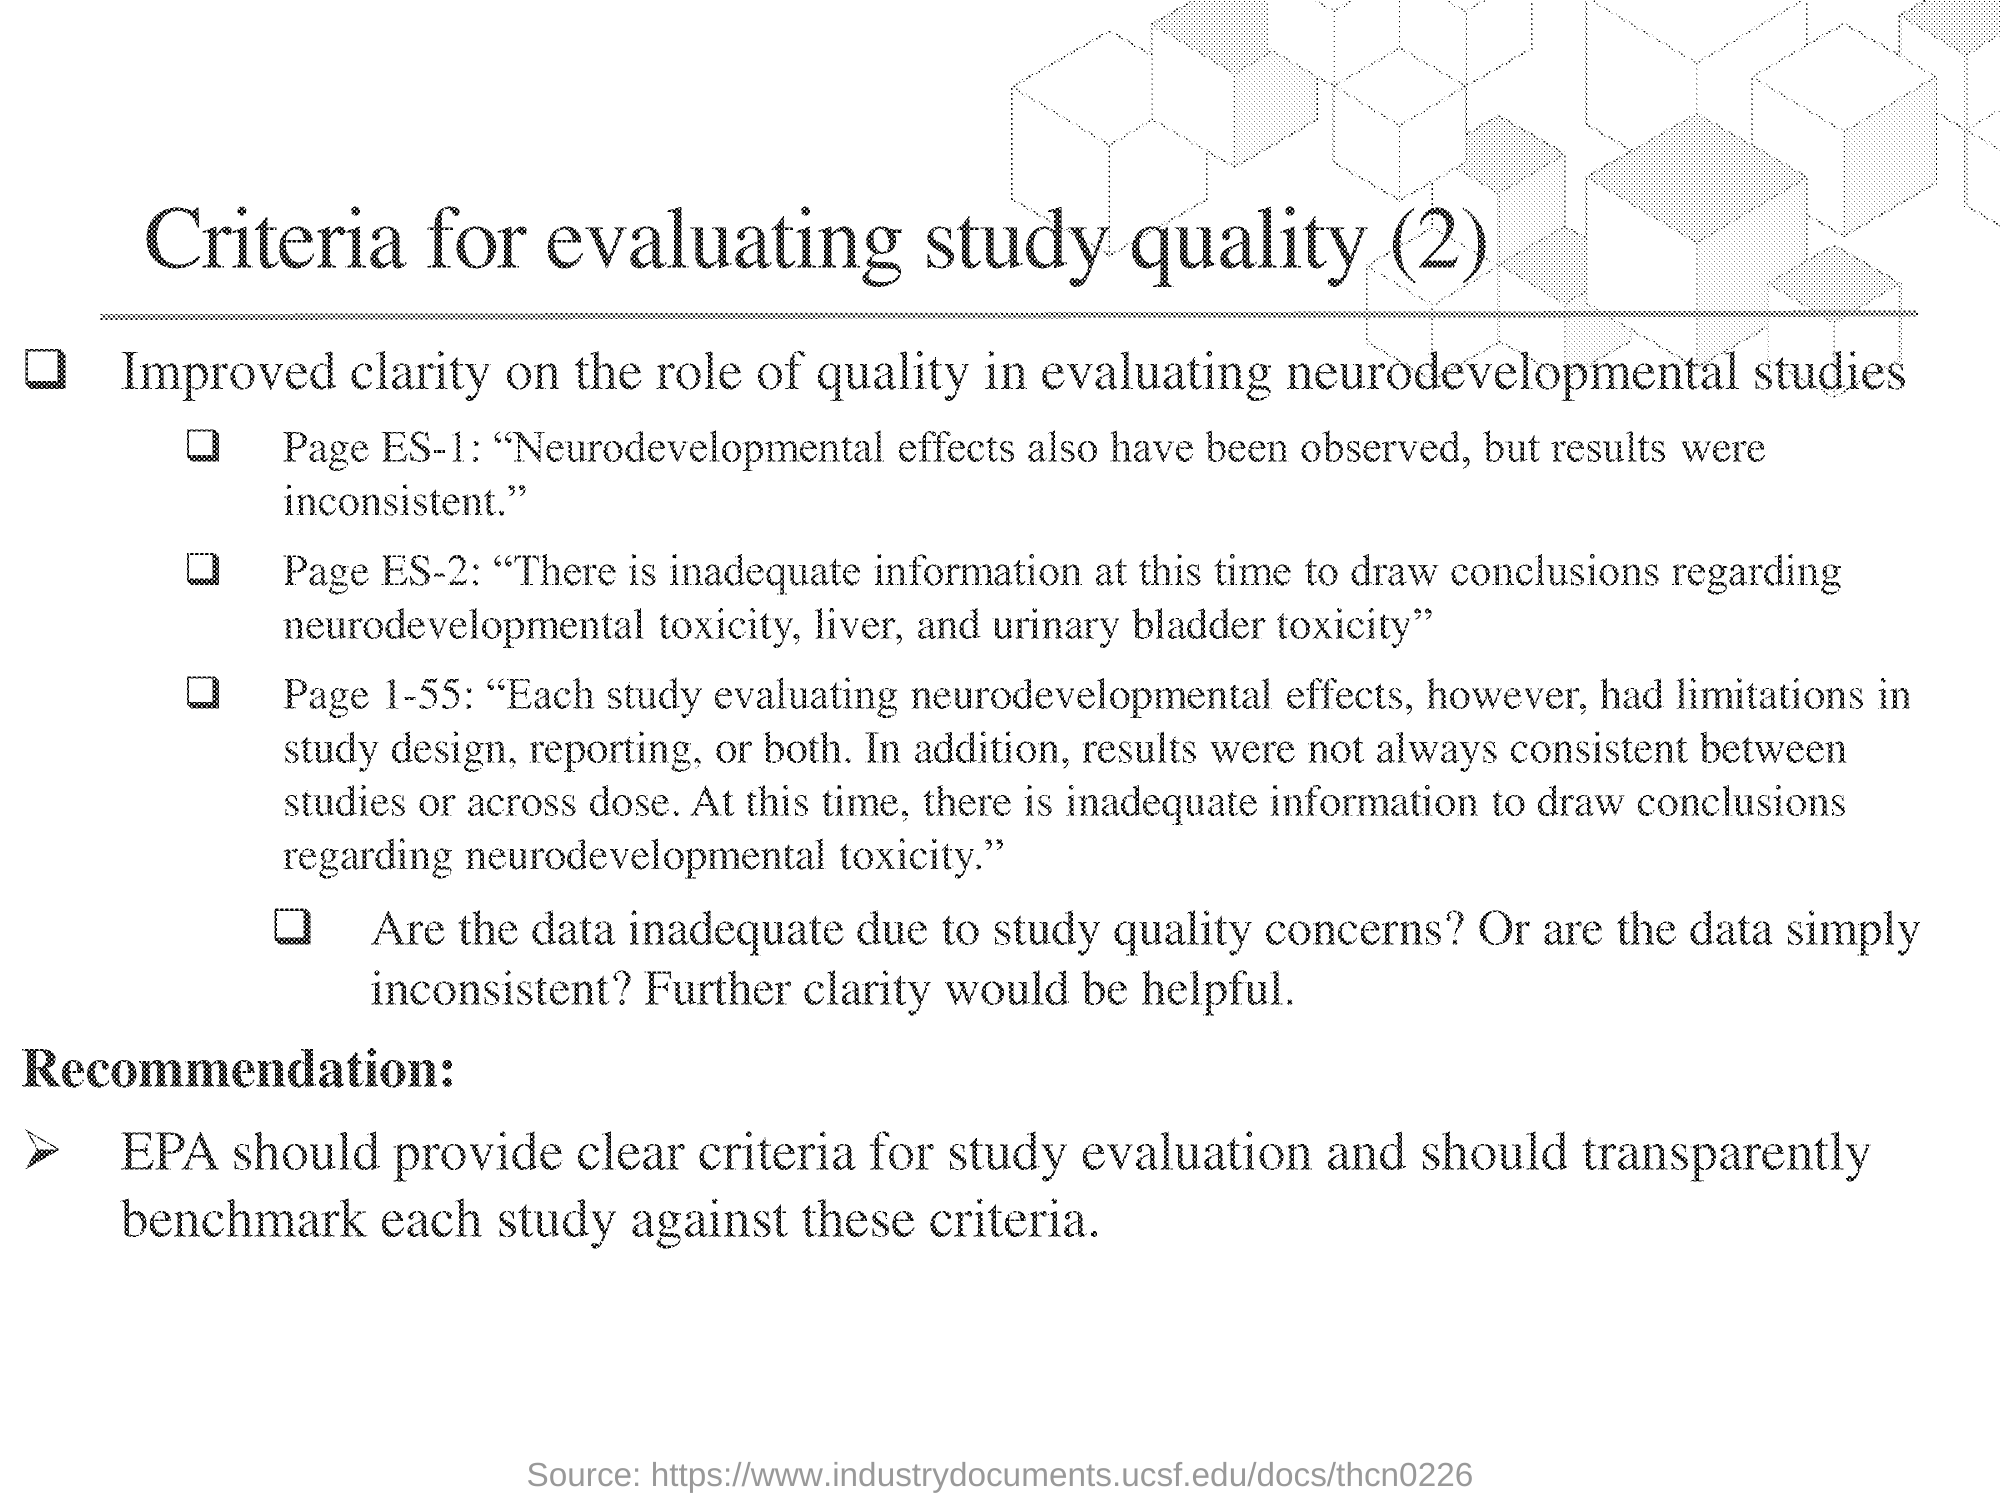Give some essential details in this illustration. The heading of the document is 'Criteria for evaluating study quality,' and the second criterion is 'What is the heading of the document?' 